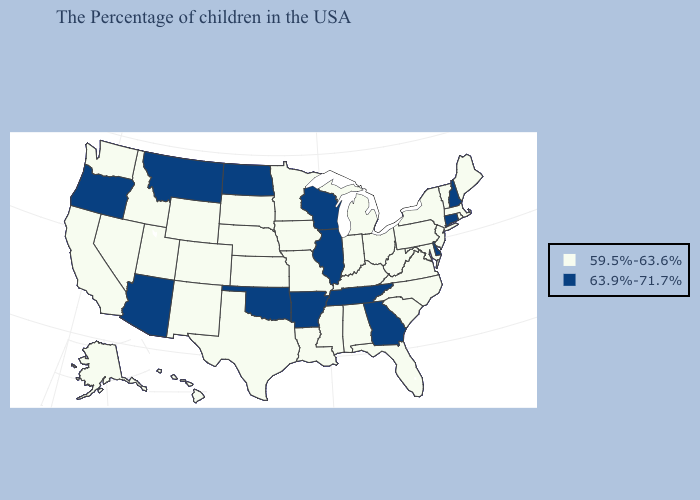Does the map have missing data?
Concise answer only. No. What is the value of Texas?
Be succinct. 59.5%-63.6%. Does the map have missing data?
Be succinct. No. Does Delaware have the highest value in the USA?
Concise answer only. Yes. Name the states that have a value in the range 59.5%-63.6%?
Give a very brief answer. Maine, Massachusetts, Rhode Island, Vermont, New York, New Jersey, Maryland, Pennsylvania, Virginia, North Carolina, South Carolina, West Virginia, Ohio, Florida, Michigan, Kentucky, Indiana, Alabama, Mississippi, Louisiana, Missouri, Minnesota, Iowa, Kansas, Nebraska, Texas, South Dakota, Wyoming, Colorado, New Mexico, Utah, Idaho, Nevada, California, Washington, Alaska, Hawaii. What is the value of Connecticut?
Be succinct. 63.9%-71.7%. What is the lowest value in the South?
Be succinct. 59.5%-63.6%. Does Oregon have the same value as Oklahoma?
Keep it brief. Yes. Does the map have missing data?
Short answer required. No. What is the lowest value in states that border Montana?
Give a very brief answer. 59.5%-63.6%. Which states hav the highest value in the South?
Short answer required. Delaware, Georgia, Tennessee, Arkansas, Oklahoma. Among the states that border New Jersey , does Delaware have the highest value?
Be succinct. Yes. Does Tennessee have the same value as New Hampshire?
Answer briefly. Yes. Does the map have missing data?
Keep it brief. No. 